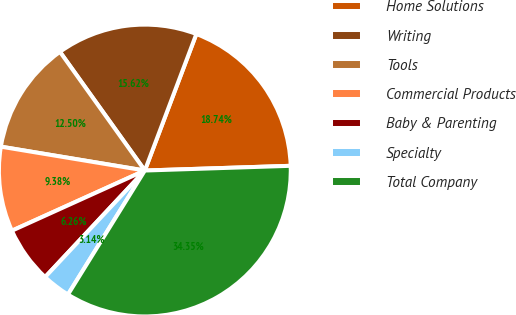Convert chart. <chart><loc_0><loc_0><loc_500><loc_500><pie_chart><fcel>Home Solutions<fcel>Writing<fcel>Tools<fcel>Commercial Products<fcel>Baby & Parenting<fcel>Specialty<fcel>Total Company<nl><fcel>18.74%<fcel>15.62%<fcel>12.5%<fcel>9.38%<fcel>6.26%<fcel>3.14%<fcel>34.34%<nl></chart> 